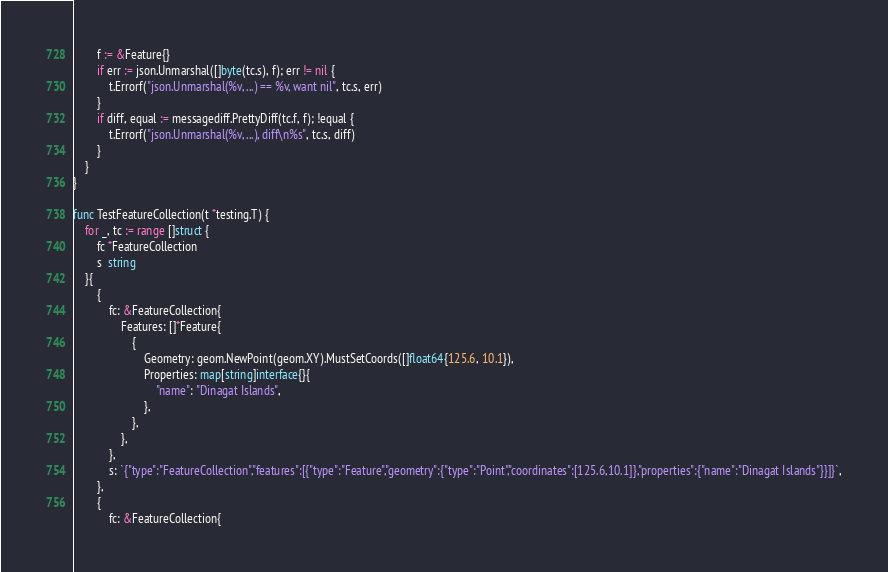Convert code to text. <code><loc_0><loc_0><loc_500><loc_500><_Go_>		f := &Feature{}
		if err := json.Unmarshal([]byte(tc.s), f); err != nil {
			t.Errorf("json.Unmarshal(%v, ...) == %v, want nil", tc.s, err)
		}
		if diff, equal := messagediff.PrettyDiff(tc.f, f); !equal {
			t.Errorf("json.Unmarshal(%v, ...), diff\n%s", tc.s, diff)
		}
	}
}

func TestFeatureCollection(t *testing.T) {
	for _, tc := range []struct {
		fc *FeatureCollection
		s  string
	}{
		{
			fc: &FeatureCollection{
				Features: []*Feature{
					{
						Geometry: geom.NewPoint(geom.XY).MustSetCoords([]float64{125.6, 10.1}),
						Properties: map[string]interface{}{
							"name": "Dinagat Islands",
						},
					},
				},
			},
			s: `{"type":"FeatureCollection","features":[{"type":"Feature","geometry":{"type":"Point","coordinates":[125.6,10.1]},"properties":{"name":"Dinagat Islands"}}]}`,
		},
		{
			fc: &FeatureCollection{</code> 